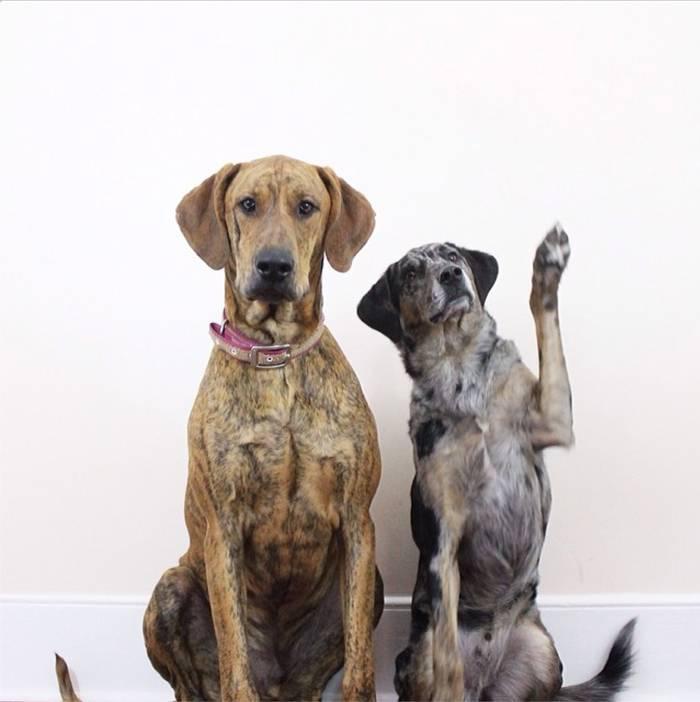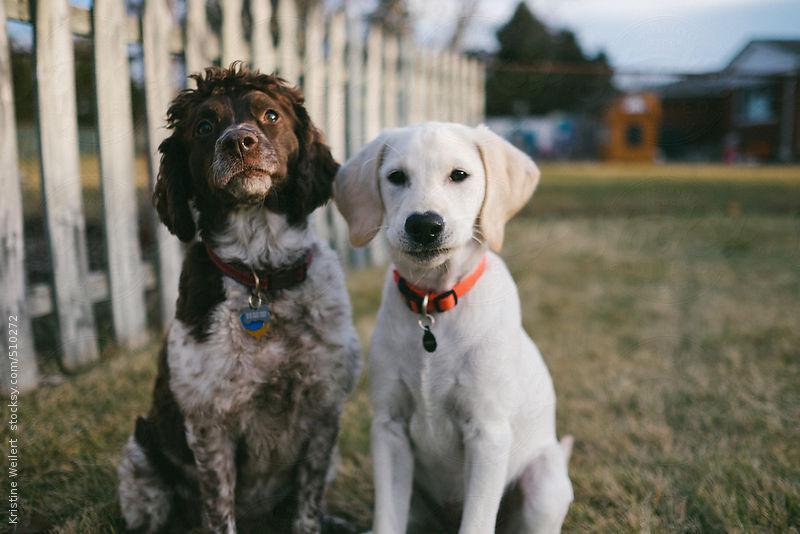The first image is the image on the left, the second image is the image on the right. Examine the images to the left and right. Is the description "The image on the right shows two dogs sitting next to each other outside." accurate? Answer yes or no. Yes. 